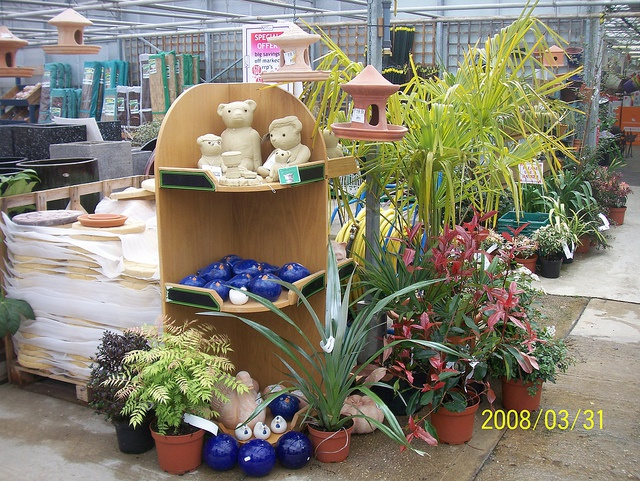Describe the objects in this image and their specific colors. I can see potted plant in blue, black, gray, brown, and maroon tones, potted plant in blue, olive, darkgreen, black, and khaki tones, potted plant in blue, gray, darkgreen, black, and darkgray tones, potted plant in blue, black, maroon, gray, and brown tones, and potted plant in blue, black, gray, darkgray, and lightgray tones in this image. 